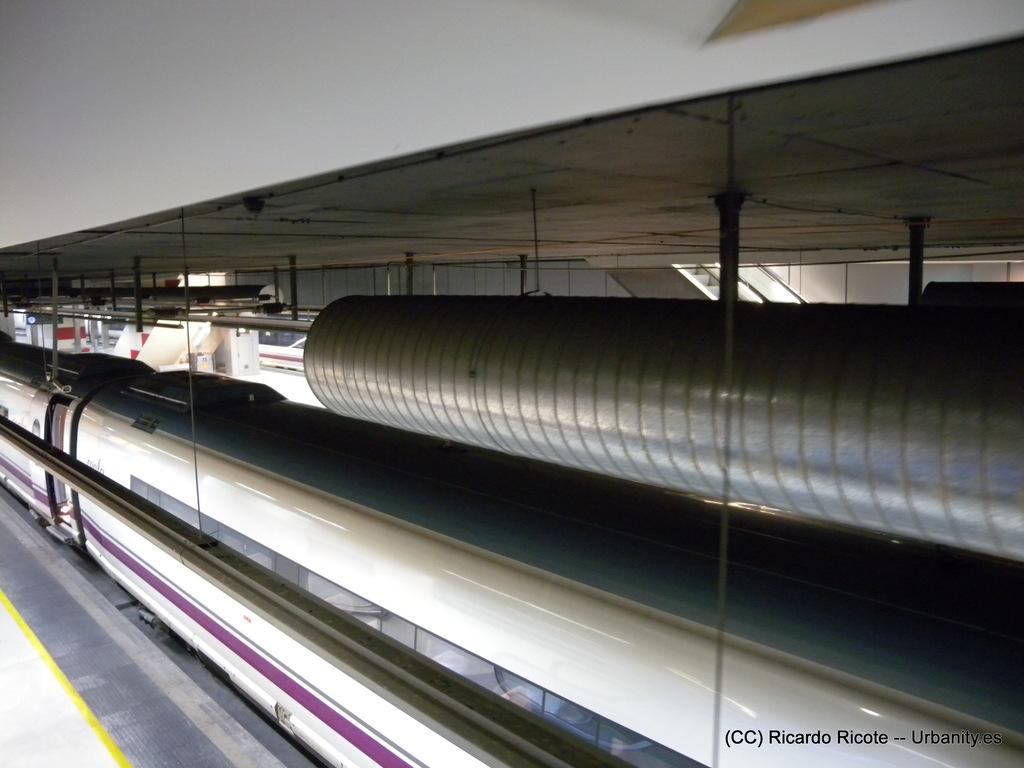Please provide a concise description of this image. In this picture there is a train. On the right side of the image there is a staircase and there is a metal pipe. On the left side of the image there is a staircase and there is a train. At the bottom right there is a text. 